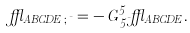Convert formula to latex. <formula><loc_0><loc_0><loc_500><loc_500>\epsilon _ { A B C D E \, ; \, \mu } = - \, G ^ { 5 } _ { \, 5 \mu } \epsilon _ { A B C D E } .</formula> 